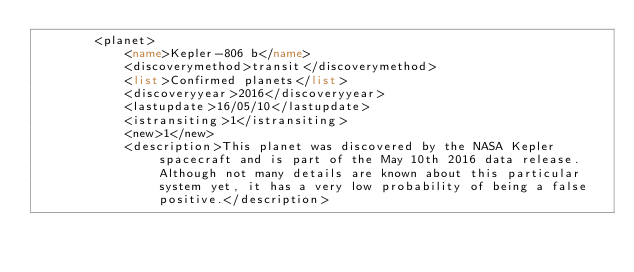Convert code to text. <code><loc_0><loc_0><loc_500><loc_500><_XML_>		<planet>
			<name>Kepler-806 b</name>
			<discoverymethod>transit</discoverymethod>
			<list>Confirmed planets</list>
			<discoveryyear>2016</discoveryyear>
			<lastupdate>16/05/10</lastupdate>
			<istransiting>1</istransiting>
			<new>1</new>
			<description>This planet was discovered by the NASA Kepler spacecraft and is part of the May 10th 2016 data release. Although not many details are known about this particular system yet, it has a very low probability of being a false positive.</description></code> 